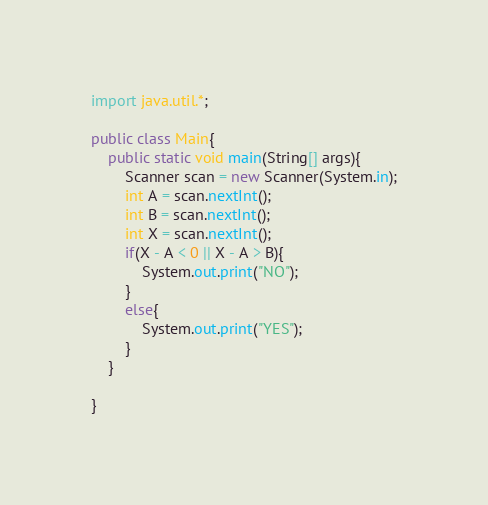Convert code to text. <code><loc_0><loc_0><loc_500><loc_500><_Java_>import java.util.*;
 
public class Main{
	public static void main(String[] args){
    	Scanner scan = new Scanner(System.in);
		int A = scan.nextInt();
      	int B = scan.nextInt();
      	int X = scan.nextInt();
      	if(X - A < 0 || X - A > B){
        	System.out.print("NO");
        }
      	else{
        	System.out.print("YES");
        }
    }
 
}</code> 